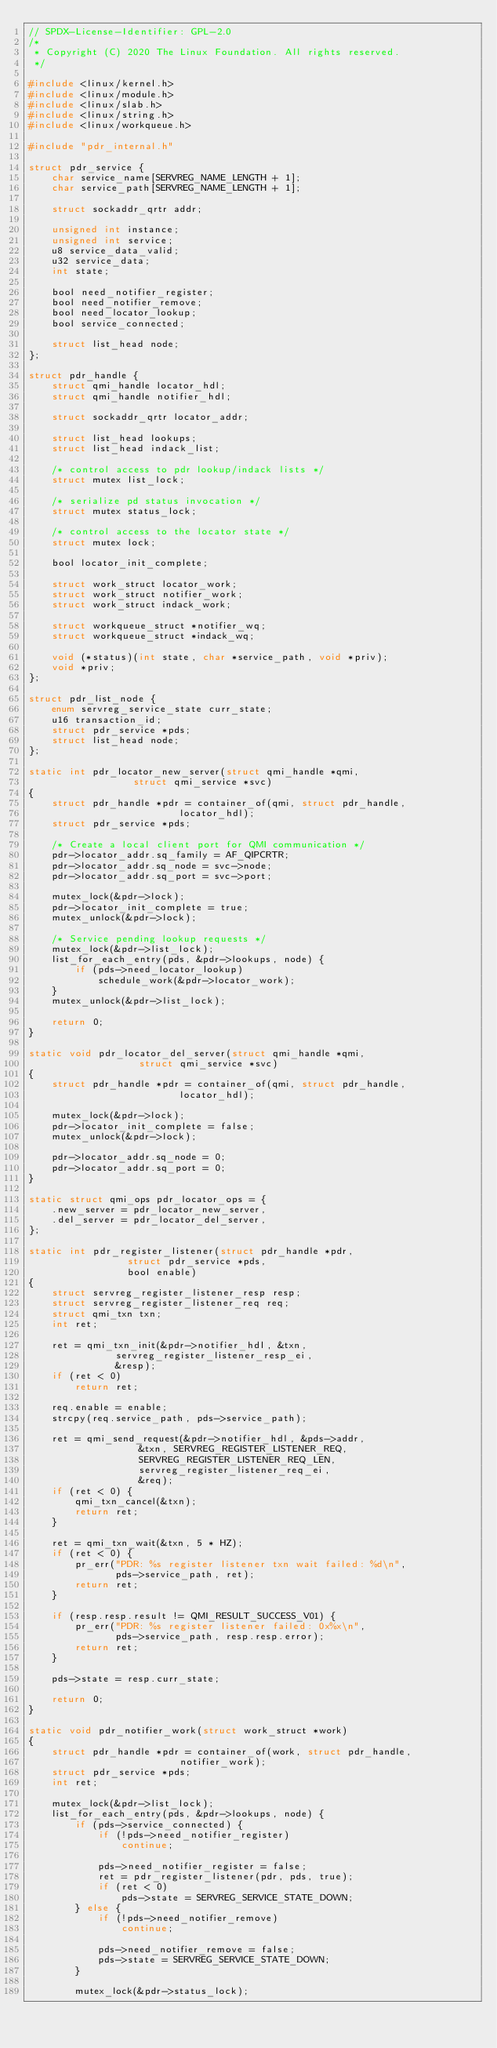<code> <loc_0><loc_0><loc_500><loc_500><_C_>// SPDX-License-Identifier: GPL-2.0
/*
 * Copyright (C) 2020 The Linux Foundation. All rights reserved.
 */

#include <linux/kernel.h>
#include <linux/module.h>
#include <linux/slab.h>
#include <linux/string.h>
#include <linux/workqueue.h>

#include "pdr_internal.h"

struct pdr_service {
	char service_name[SERVREG_NAME_LENGTH + 1];
	char service_path[SERVREG_NAME_LENGTH + 1];

	struct sockaddr_qrtr addr;

	unsigned int instance;
	unsigned int service;
	u8 service_data_valid;
	u32 service_data;
	int state;

	bool need_notifier_register;
	bool need_notifier_remove;
	bool need_locator_lookup;
	bool service_connected;

	struct list_head node;
};

struct pdr_handle {
	struct qmi_handle locator_hdl;
	struct qmi_handle notifier_hdl;

	struct sockaddr_qrtr locator_addr;

	struct list_head lookups;
	struct list_head indack_list;

	/* control access to pdr lookup/indack lists */
	struct mutex list_lock;

	/* serialize pd status invocation */
	struct mutex status_lock;

	/* control access to the locator state */
	struct mutex lock;

	bool locator_init_complete;

	struct work_struct locator_work;
	struct work_struct notifier_work;
	struct work_struct indack_work;

	struct workqueue_struct *notifier_wq;
	struct workqueue_struct *indack_wq;

	void (*status)(int state, char *service_path, void *priv);
	void *priv;
};

struct pdr_list_node {
	enum servreg_service_state curr_state;
	u16 transaction_id;
	struct pdr_service *pds;
	struct list_head node;
};

static int pdr_locator_new_server(struct qmi_handle *qmi,
				  struct qmi_service *svc)
{
	struct pdr_handle *pdr = container_of(qmi, struct pdr_handle,
					      locator_hdl);
	struct pdr_service *pds;

	/* Create a local client port for QMI communication */
	pdr->locator_addr.sq_family = AF_QIPCRTR;
	pdr->locator_addr.sq_node = svc->node;
	pdr->locator_addr.sq_port = svc->port;

	mutex_lock(&pdr->lock);
	pdr->locator_init_complete = true;
	mutex_unlock(&pdr->lock);

	/* Service pending lookup requests */
	mutex_lock(&pdr->list_lock);
	list_for_each_entry(pds, &pdr->lookups, node) {
		if (pds->need_locator_lookup)
			schedule_work(&pdr->locator_work);
	}
	mutex_unlock(&pdr->list_lock);

	return 0;
}

static void pdr_locator_del_server(struct qmi_handle *qmi,
				   struct qmi_service *svc)
{
	struct pdr_handle *pdr = container_of(qmi, struct pdr_handle,
					      locator_hdl);

	mutex_lock(&pdr->lock);
	pdr->locator_init_complete = false;
	mutex_unlock(&pdr->lock);

	pdr->locator_addr.sq_node = 0;
	pdr->locator_addr.sq_port = 0;
}

static struct qmi_ops pdr_locator_ops = {
	.new_server = pdr_locator_new_server,
	.del_server = pdr_locator_del_server,
};

static int pdr_register_listener(struct pdr_handle *pdr,
				 struct pdr_service *pds,
				 bool enable)
{
	struct servreg_register_listener_resp resp;
	struct servreg_register_listener_req req;
	struct qmi_txn txn;
	int ret;

	ret = qmi_txn_init(&pdr->notifier_hdl, &txn,
			   servreg_register_listener_resp_ei,
			   &resp);
	if (ret < 0)
		return ret;

	req.enable = enable;
	strcpy(req.service_path, pds->service_path);

	ret = qmi_send_request(&pdr->notifier_hdl, &pds->addr,
			       &txn, SERVREG_REGISTER_LISTENER_REQ,
			       SERVREG_REGISTER_LISTENER_REQ_LEN,
			       servreg_register_listener_req_ei,
			       &req);
	if (ret < 0) {
		qmi_txn_cancel(&txn);
		return ret;
	}

	ret = qmi_txn_wait(&txn, 5 * HZ);
	if (ret < 0) {
		pr_err("PDR: %s register listener txn wait failed: %d\n",
		       pds->service_path, ret);
		return ret;
	}

	if (resp.resp.result != QMI_RESULT_SUCCESS_V01) {
		pr_err("PDR: %s register listener failed: 0x%x\n",
		       pds->service_path, resp.resp.error);
		return ret;
	}

	pds->state = resp.curr_state;

	return 0;
}

static void pdr_notifier_work(struct work_struct *work)
{
	struct pdr_handle *pdr = container_of(work, struct pdr_handle,
					      notifier_work);
	struct pdr_service *pds;
	int ret;

	mutex_lock(&pdr->list_lock);
	list_for_each_entry(pds, &pdr->lookups, node) {
		if (pds->service_connected) {
			if (!pds->need_notifier_register)
				continue;

			pds->need_notifier_register = false;
			ret = pdr_register_listener(pdr, pds, true);
			if (ret < 0)
				pds->state = SERVREG_SERVICE_STATE_DOWN;
		} else {
			if (!pds->need_notifier_remove)
				continue;

			pds->need_notifier_remove = false;
			pds->state = SERVREG_SERVICE_STATE_DOWN;
		}

		mutex_lock(&pdr->status_lock);</code> 